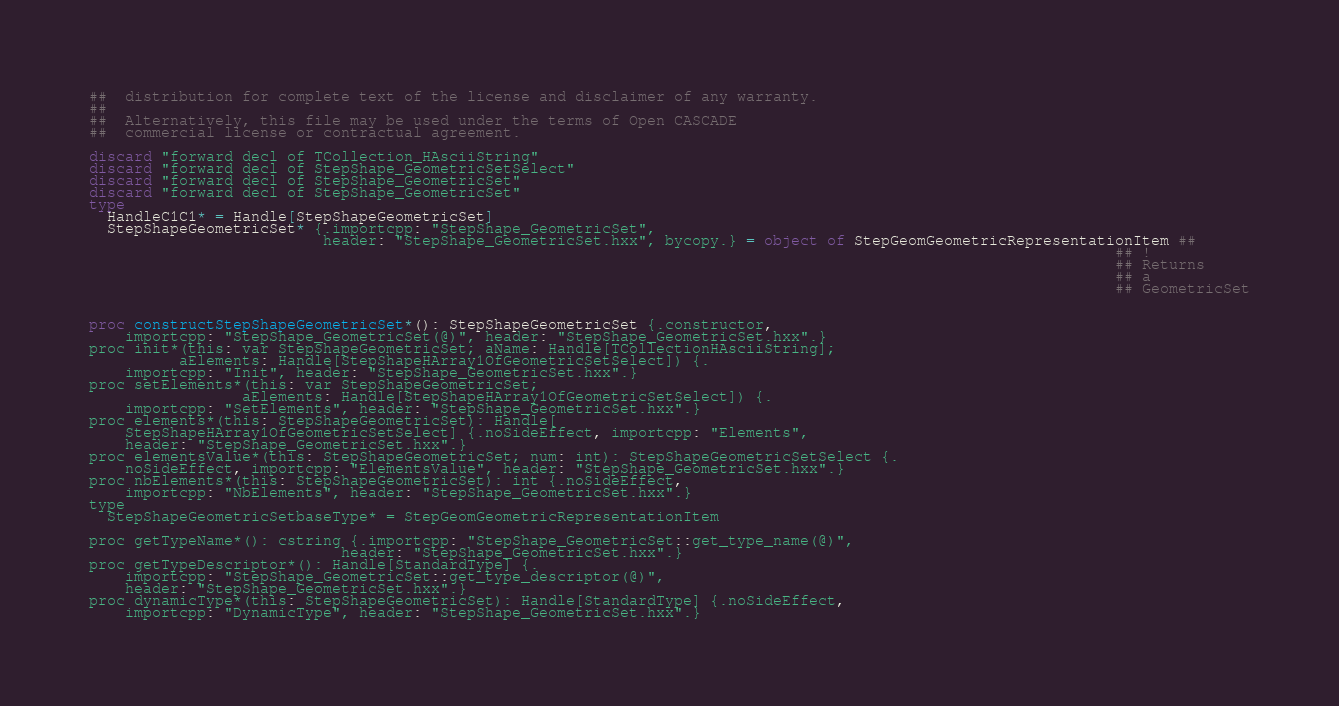<code> <loc_0><loc_0><loc_500><loc_500><_Nim_>##  distribution for complete text of the license and disclaimer of any warranty.
##
##  Alternatively, this file may be used under the terms of Open CASCADE
##  commercial license or contractual agreement.

discard "forward decl of TCollection_HAsciiString"
discard "forward decl of StepShape_GeometricSetSelect"
discard "forward decl of StepShape_GeometricSet"
discard "forward decl of StepShape_GeometricSet"
type
  HandleC1C1* = Handle[StepShapeGeometricSet]
  StepShapeGeometricSet* {.importcpp: "StepShape_GeometricSet",
                          header: "StepShape_GeometricSet.hxx", bycopy.} = object of StepGeomGeometricRepresentationItem ##
                                                                                                                  ## !
                                                                                                                  ## Returns
                                                                                                                  ## a
                                                                                                                  ## GeometricSet


proc constructStepShapeGeometricSet*(): StepShapeGeometricSet {.constructor,
    importcpp: "StepShape_GeometricSet(@)", header: "StepShape_GeometricSet.hxx".}
proc init*(this: var StepShapeGeometricSet; aName: Handle[TCollectionHAsciiString];
          aElements: Handle[StepShapeHArray1OfGeometricSetSelect]) {.
    importcpp: "Init", header: "StepShape_GeometricSet.hxx".}
proc setElements*(this: var StepShapeGeometricSet;
                 aElements: Handle[StepShapeHArray1OfGeometricSetSelect]) {.
    importcpp: "SetElements", header: "StepShape_GeometricSet.hxx".}
proc elements*(this: StepShapeGeometricSet): Handle[
    StepShapeHArray1OfGeometricSetSelect] {.noSideEffect, importcpp: "Elements",
    header: "StepShape_GeometricSet.hxx".}
proc elementsValue*(this: StepShapeGeometricSet; num: int): StepShapeGeometricSetSelect {.
    noSideEffect, importcpp: "ElementsValue", header: "StepShape_GeometricSet.hxx".}
proc nbElements*(this: StepShapeGeometricSet): int {.noSideEffect,
    importcpp: "NbElements", header: "StepShape_GeometricSet.hxx".}
type
  StepShapeGeometricSetbaseType* = StepGeomGeometricRepresentationItem

proc getTypeName*(): cstring {.importcpp: "StepShape_GeometricSet::get_type_name(@)",
                            header: "StepShape_GeometricSet.hxx".}
proc getTypeDescriptor*(): Handle[StandardType] {.
    importcpp: "StepShape_GeometricSet::get_type_descriptor(@)",
    header: "StepShape_GeometricSet.hxx".}
proc dynamicType*(this: StepShapeGeometricSet): Handle[StandardType] {.noSideEffect,
    importcpp: "DynamicType", header: "StepShape_GeometricSet.hxx".}</code> 